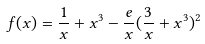<formula> <loc_0><loc_0><loc_500><loc_500>f ( x ) = \frac { 1 } { x } + x ^ { 3 } - \frac { e } { x } ( \frac { 3 } { x } + x ^ { 3 } ) ^ { 2 }</formula> 